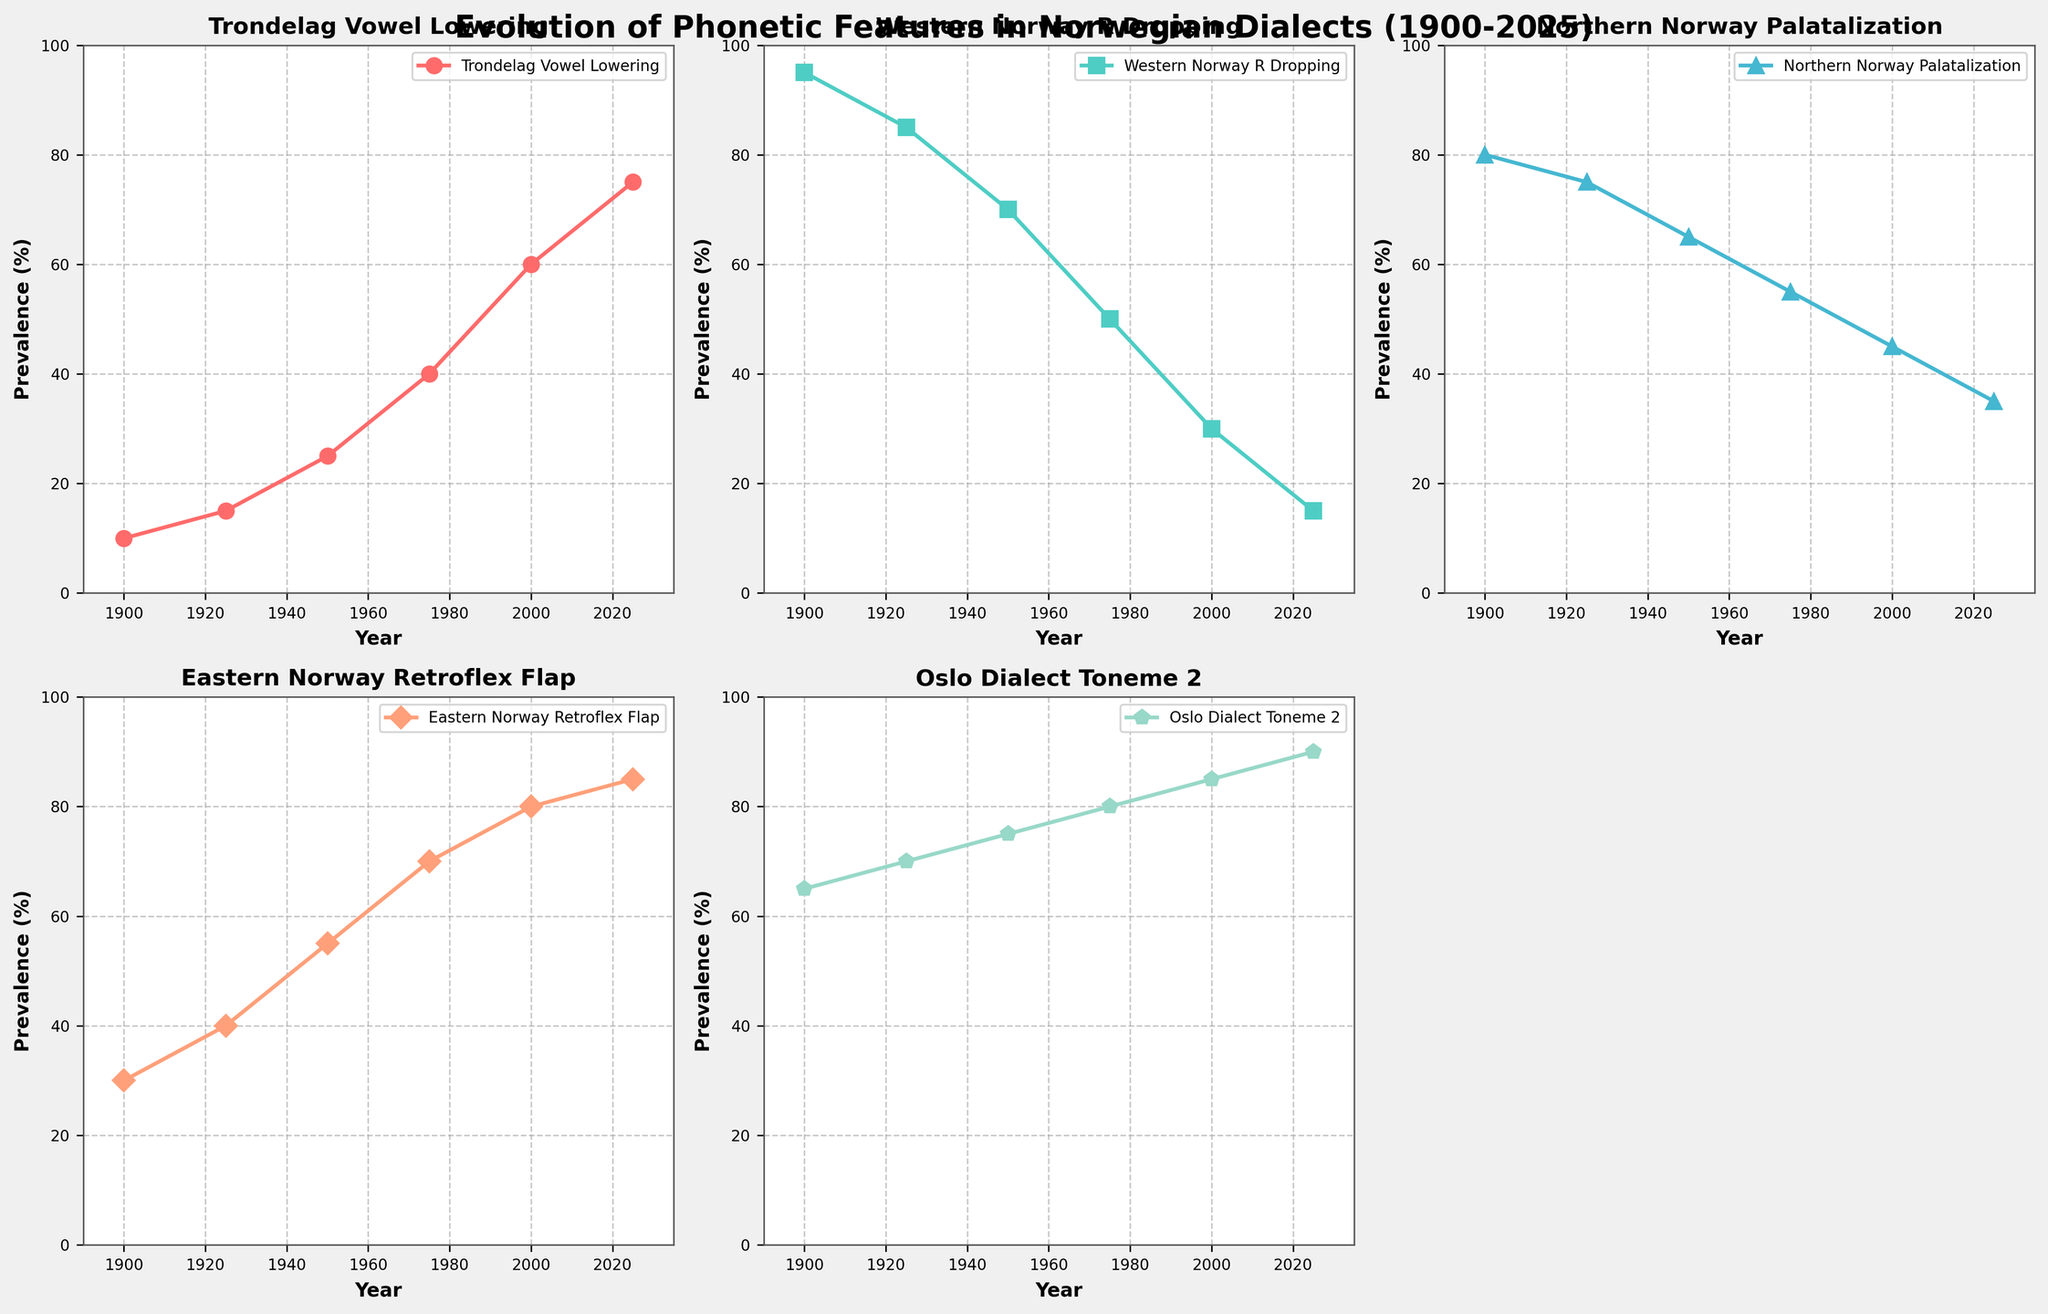How many subplots are present in the figure? The figure has a title stating "Evolution of Phonetic Features in Norwegian Dialects (1900-2025)" and divides the data into different dialect features across subplots. We can count 6 positions, but only 5 are used as one subplot is removed.
Answer: 5 What is the range of years displayed on the x-axis for each subplot? Each subplot shows data points marked by the years, and the x-axis clearly indicates this range. Inspecting the x-axis, it spans from a little before 1900 to just after 2025.
Answer: 1890 to 2035 Which dialect feature shows the greatest increase in prevalence over the time period? To determine which line shows the greatest increase in prevalence, we examine each subplot and calculate the change from 1900 to 2025. Trøndelag Vowel Lowering increases from 10 to 75, a rise of 65, which is the largest among the plotted data.
Answer: Trøndelag Vowel Lowering In which year does Western Norway R-Dropping show a prevalence of about 50%? Looking at the line chart for Western Norway R-Dropping, we identify the point where the line crosses the 50% mark. By examining the x-axis, this value occurs around 1975.
Answer: 1975 Between 1900 and 2025, which dialect feature shows a consistent decline in prevalence? Observing the slopes and trends for each line throughout the subplots, only Western Norway R-Dropping shows a steady decrease from 95 in 1900 to 15 in 2025.
Answer: Western Norway R-Dropping How many phonetic features have a prevalence greater than 70% by 2025? We look at the end points of each line in the subplots corresponding to the year 2025. Trøndelag Vowel Lowering (75), Eastern Norway Retroflex Flap (85), and Oslo Dialect Toneme 2 (90) are the phonetic features above 70%.
Answer: 3 Compare the prevalence of Northern Norway Palatalization in 1950 with Eastern Norway Retroflex Flap in 2000. Which is higher? Locate the points on the respective subplots for Northern Norway Palatalization in 1950 and Eastern Norway Retroflex Flap in 2000. Northern Norway Palatalization is at 65, and Eastern Norway Retroflex Flap is at 80.
Answer: Eastern Norway Retroflex Flap Which phonetic feature experienced the sharpest decline in a single time period? Analyze each line segment between time periods for steep declines. The Western Norway R-Dropping from 1950 to 1975 shows the steepest drop, going from 70 to 50, a decline of 20%.
Answer: Western Norway R-Dropping (1950-1975) On average, what is the prevalence of the Oslo Dialect Toneme 2 from 1900 to 2000? Calculate the average of values for Oslo Dialect Toneme 2 over five years: (65 + 70 + 75 + 80 + 85) / 5 = 75
Answer: 75 Which year marks the highest prevalence for Eastern Norway Retroflex Flap? Examine the subplot for Eastern Norway Retroflex Flap and identify the data point with the maximum value. The highest point is 85 in 2025.
Answer: 2025 